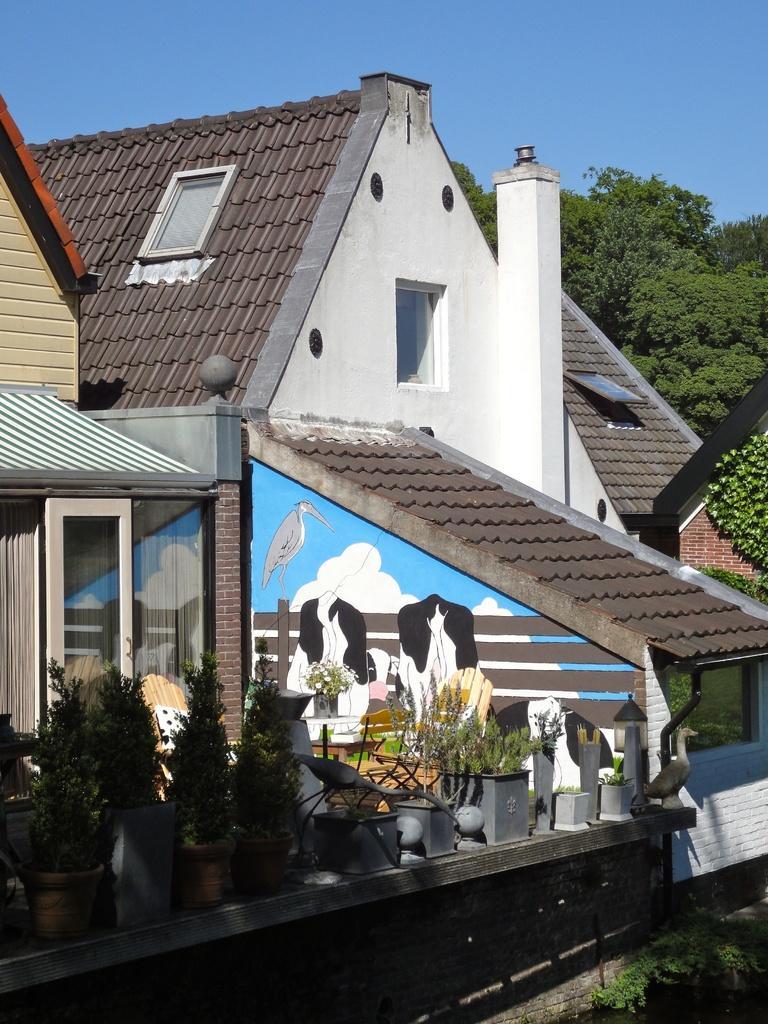How would you summarize this image in a sentence or two? In the picture I can see buildings, trees, plant pots, paintings on the wall and some other objects. In the background I can see the sky. 